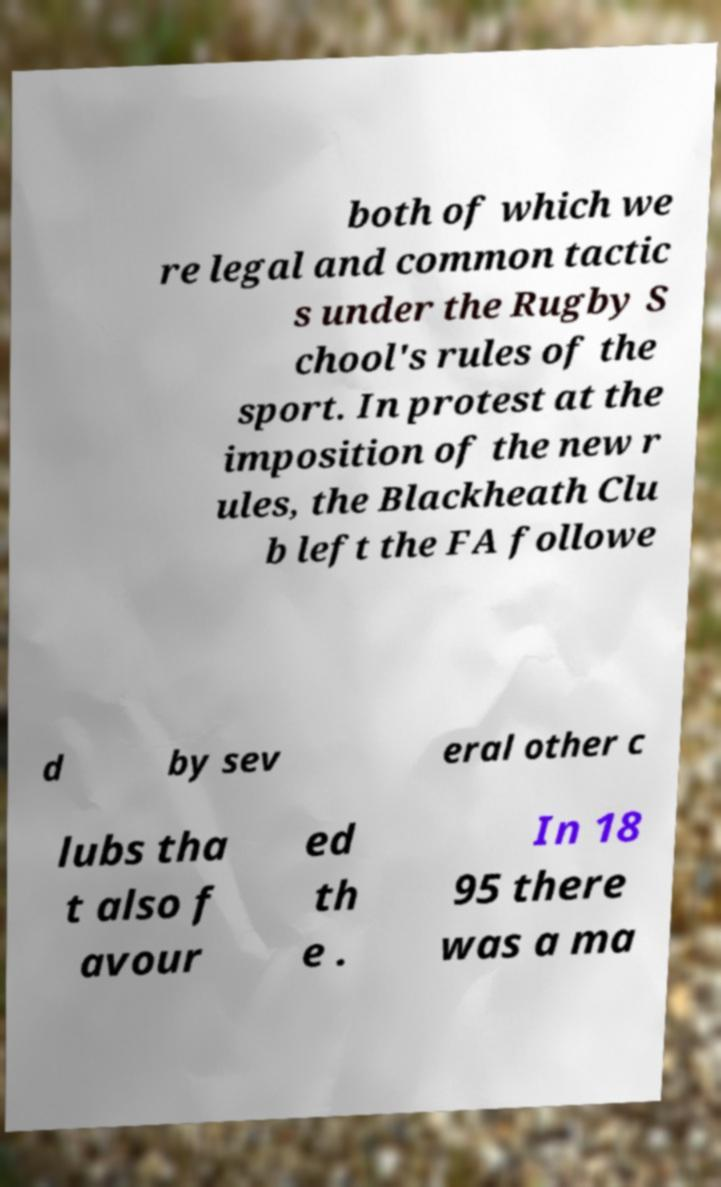Could you assist in decoding the text presented in this image and type it out clearly? both of which we re legal and common tactic s under the Rugby S chool's rules of the sport. In protest at the imposition of the new r ules, the Blackheath Clu b left the FA followe d by sev eral other c lubs tha t also f avour ed th e . In 18 95 there was a ma 